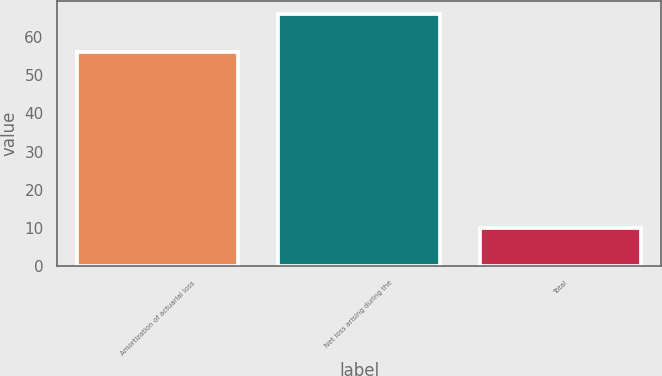<chart> <loc_0><loc_0><loc_500><loc_500><bar_chart><fcel>Amortization of actuarial loss<fcel>Net loss arising during the<fcel>Total<nl><fcel>56<fcel>66<fcel>10<nl></chart> 